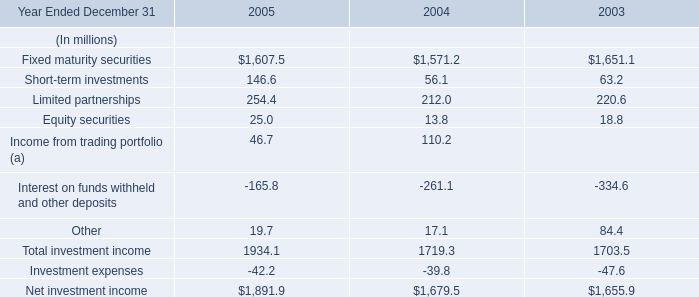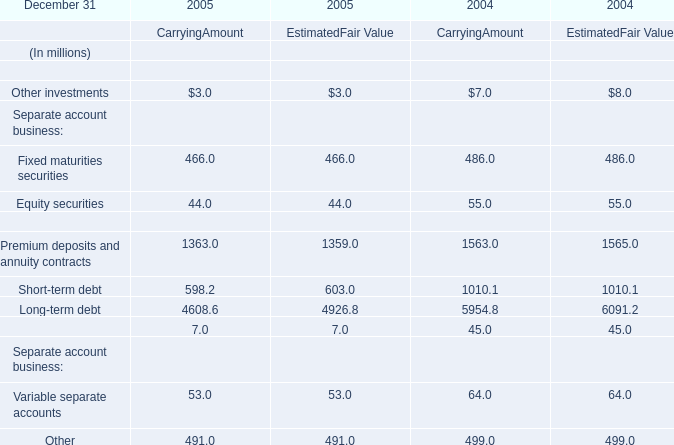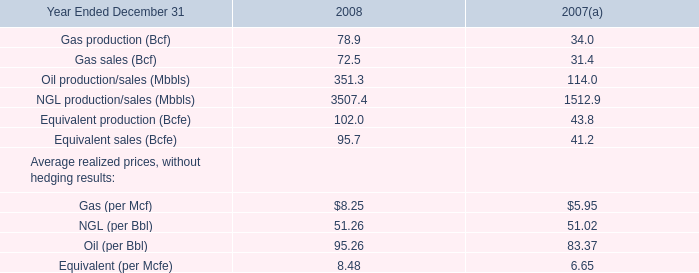What's the Carrying Amount of the Equity securities in the year where Carrying Amount of Fixed maturities securities is greater than 470 million? 
Answer: 55.0. 